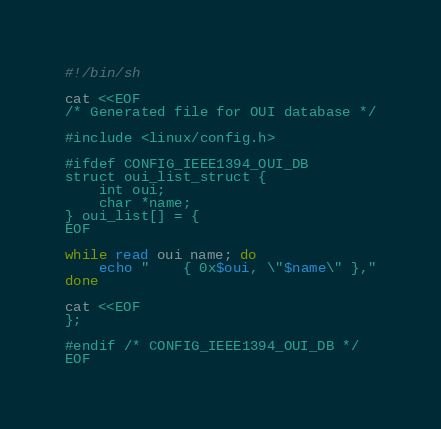<code> <loc_0><loc_0><loc_500><loc_500><_Bash_>#!/bin/sh

cat <<EOF
/* Generated file for OUI database */

#include <linux/config.h>

#ifdef CONFIG_IEEE1394_OUI_DB
struct oui_list_struct {
	int oui;
	char *name;
} oui_list[] = {
EOF

while read oui name; do
	echo "	{ 0x$oui, \"$name\" },"
done

cat <<EOF
};

#endif /* CONFIG_IEEE1394_OUI_DB */
EOF
</code> 